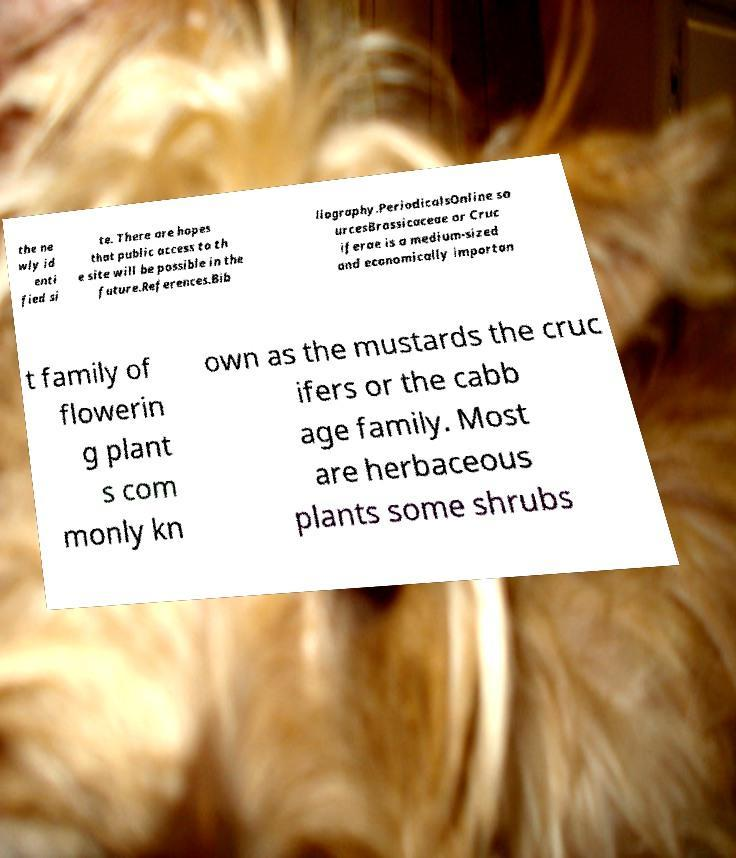Can you read and provide the text displayed in the image?This photo seems to have some interesting text. Can you extract and type it out for me? the ne wly id enti fied si te. There are hopes that public access to th e site will be possible in the future.References.Bib liography.PeriodicalsOnline so urcesBrassicaceae or Cruc iferae is a medium-sized and economically importan t family of flowerin g plant s com monly kn own as the mustards the cruc ifers or the cabb age family. Most are herbaceous plants some shrubs 